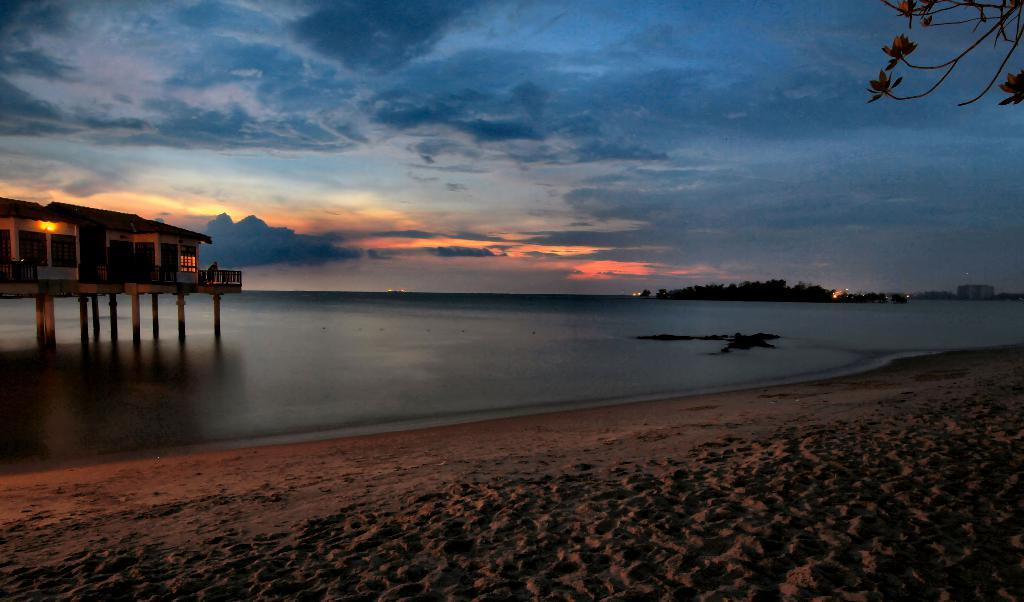What natural feature can be seen in the image? There is a river in the image. What is located above the river? There is a building above the river. What type of vegetation can be seen in the background of the image? There are trees in the background of the image. What else can be seen in the background of the image? There are buildings in the background of the image. What part of the natural environment is visible in the image? The sky is visible in the background of the image. What type of reward is being given to the floor in the image? There is no reward being given to the floor in the image, as the image does not depict any rewards or floors. 